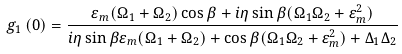Convert formula to latex. <formula><loc_0><loc_0><loc_500><loc_500>g _ { 1 } \left ( 0 \right ) = \frac { \varepsilon _ { m } ( \Omega _ { 1 } + \Omega _ { 2 } ) \cos \beta + i \eta \sin \beta ( \Omega _ { 1 } \Omega _ { 2 } + \varepsilon _ { m } ^ { 2 } ) } { i \eta \sin \beta \varepsilon _ { m } ( \Omega _ { 1 } + \Omega _ { 2 } ) + \cos \beta ( \Omega _ { 1 } \Omega _ { 2 } + \varepsilon _ { m } ^ { 2 } ) + \Delta _ { 1 } \Delta _ { 2 } }</formula> 